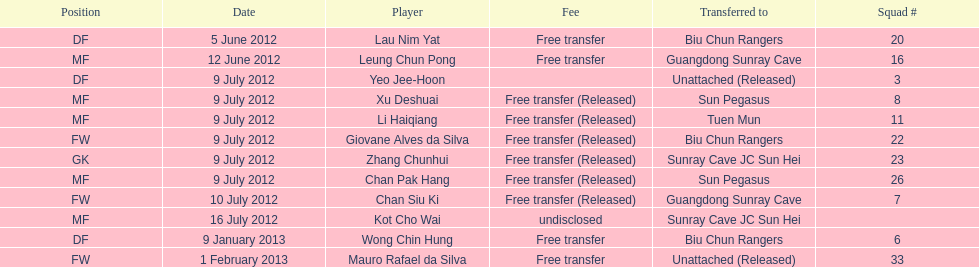What is the overall count of players mentioned? 12. 